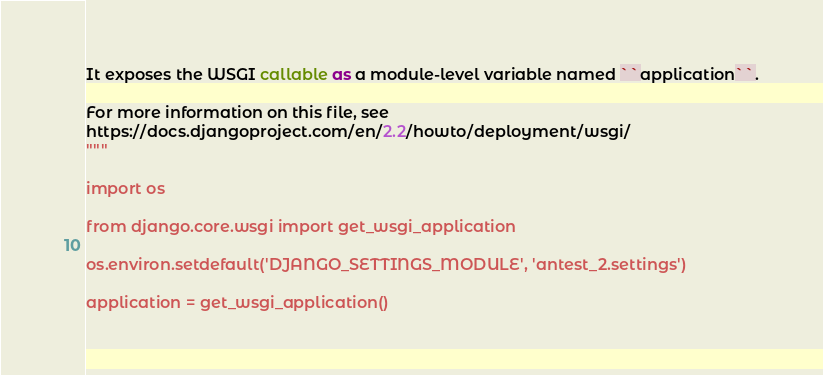<code> <loc_0><loc_0><loc_500><loc_500><_Python_>
It exposes the WSGI callable as a module-level variable named ``application``.

For more information on this file, see
https://docs.djangoproject.com/en/2.2/howto/deployment/wsgi/
"""

import os

from django.core.wsgi import get_wsgi_application

os.environ.setdefault('DJANGO_SETTINGS_MODULE', 'antest_2.settings')

application = get_wsgi_application()
</code> 